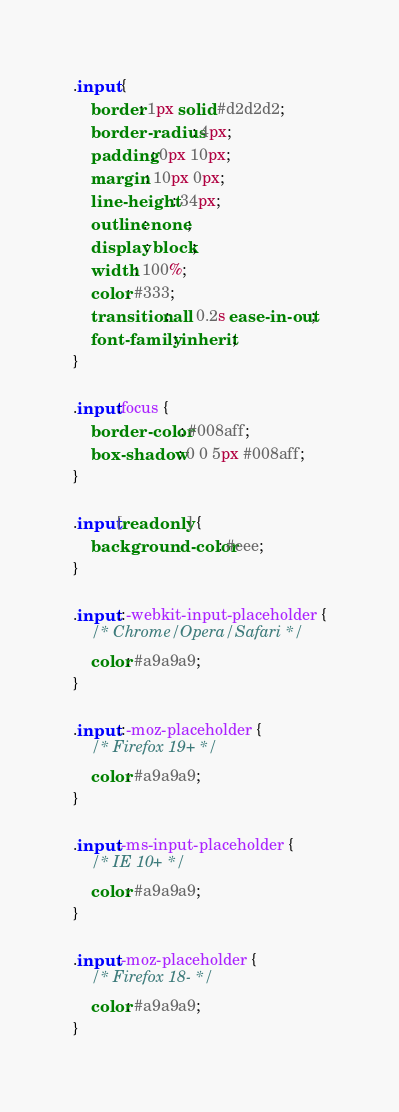<code> <loc_0><loc_0><loc_500><loc_500><_CSS_>.input {
    border: 1px solid #d2d2d2;
    border-radius: 4px;
    padding: 0px 10px;
    margin: 10px 0px;
    line-height: 34px;
    outline: none;
    display: block;
    width: 100%;
    color: #333;
    transition: all 0.2s ease-in-out;
    font-family: inherit;
}

.input:focus {
    border-color: #008aff;
    box-shadow: 0 0 5px #008aff;
}

.input[readonly] {
    background-color: #eee;
}

.input::-webkit-input-placeholder {
    /* Chrome/Opera/Safari */
    color: #a9a9a9;
}

.input::-moz-placeholder {
    /* Firefox 19+ */
    color: #a9a9a9;
}

.input:-ms-input-placeholder {
    /* IE 10+ */
    color: #a9a9a9;
}

.input:-moz-placeholder {
    /* Firefox 18- */
    color: #a9a9a9;
}</code> 